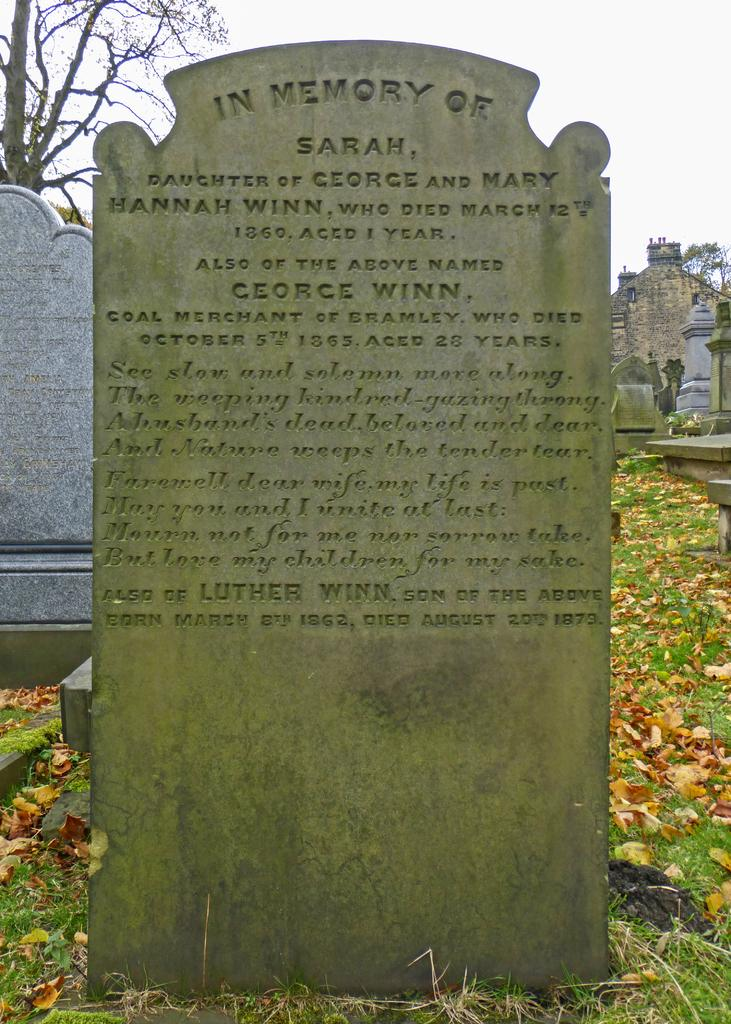What can be seen on the gravestones in the image? There is text on the gravestones in the image. What type of plant is present in the image? There is a tree in the image. What type of structure is visible in the image? There is a building in the image. What type of ground cover is present in the image? There is grass on the ground in the image. What is the condition of the sky in the image? The sky is cloudy in the image. What type of rhythm can be heard coming from the gravestones in the image? There is no sound or rhythm present in the image; it is a still photograph. How many mice are visible on the gravestones in the image? There are no mice present in the image. 